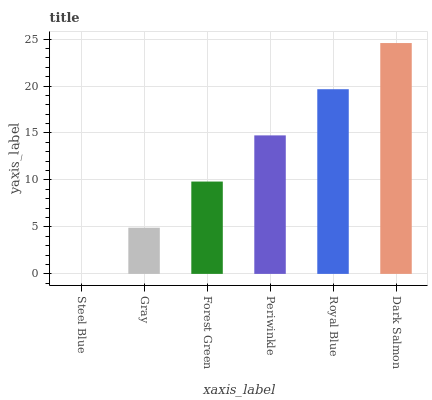Is Steel Blue the minimum?
Answer yes or no. Yes. Is Dark Salmon the maximum?
Answer yes or no. Yes. Is Gray the minimum?
Answer yes or no. No. Is Gray the maximum?
Answer yes or no. No. Is Gray greater than Steel Blue?
Answer yes or no. Yes. Is Steel Blue less than Gray?
Answer yes or no. Yes. Is Steel Blue greater than Gray?
Answer yes or no. No. Is Gray less than Steel Blue?
Answer yes or no. No. Is Periwinkle the high median?
Answer yes or no. Yes. Is Forest Green the low median?
Answer yes or no. Yes. Is Dark Salmon the high median?
Answer yes or no. No. Is Gray the low median?
Answer yes or no. No. 